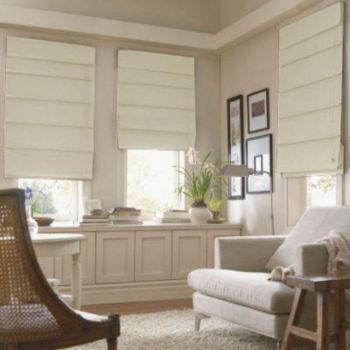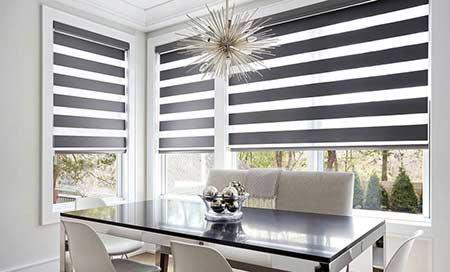The first image is the image on the left, the second image is the image on the right. Given the left and right images, does the statement "The left and right image contains a total of six blinds on the windows." hold true? Answer yes or no. Yes. The first image is the image on the left, the second image is the image on the right. Assess this claim about the two images: "At least one couch is sitting in front of the blinds.". Correct or not? Answer yes or no. No. 